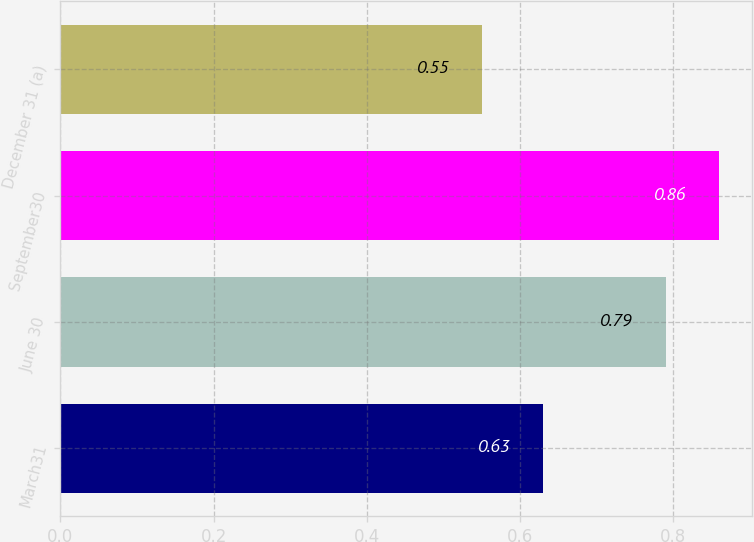Convert chart to OTSL. <chart><loc_0><loc_0><loc_500><loc_500><bar_chart><fcel>March31<fcel>June 30<fcel>September30<fcel>December 31 (a)<nl><fcel>0.63<fcel>0.79<fcel>0.86<fcel>0.55<nl></chart> 